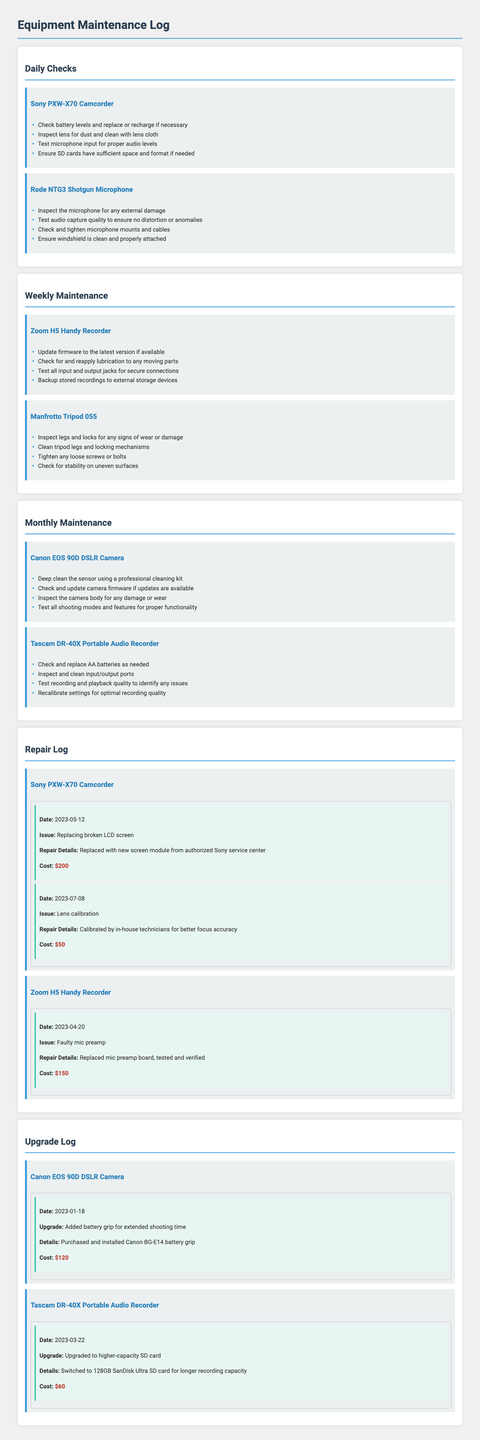What are the daily checks for the Sony PXW-X70 Camcorder? The daily checks for the Sony PXW-X70 Camcorder include checking battery levels, inspecting the lens, testing microphone input, and ensuring SD cards have sufficient space.
Answer: Check battery levels and replace or recharge if necessary, Inspect lens for dust and clean with lens cloth, Test microphone input for proper audio levels, Ensure SD cards have sufficient space and format if needed What was the repair cost for the faulty mic preamp on the Zoom H5 Handy Recorder? The repair cost for the faulty mic preamp is listed under the repair log for the Zoom H5 Handy Recorder.
Answer: $150 What maintenance tasks are performed monthly for the Canon EOS 90D DSLR Camera? Monthly maintenance tasks for the Canon EOS 90D DSLR Camera include deep cleaning the sensor, checking and updating firmware, inspecting the camera body for damage, and testing all shooting modes.
Answer: Deep clean the sensor using a professional cleaning kit, Check and update camera firmware if updates are available, Inspect the camera body for any damage or wear, Test all shooting modes and features for proper functionality When was the lens calibration done for the Sony PXW-X70 Camcorder? The date of the lens calibration for the Sony PXW-X70 Camcorder is recorded in the repair log.
Answer: 2023-07-08 What upgrade was made to the Tascam DR-40X Portable Audio Recorder? To understand the upgrade made to the Tascam DR-40X Portable Audio Recorder, we look at the upgrade log detailing what was done.
Answer: Upgraded to higher-capacity SD card What is the cost of the upgrade for the Canon EOS 90D DSLR Camera? The cost for the upgrade of the Canon EOS 90D DSLR Camera is documented in the upgrade log, showing how much was spent.
Answer: $120 Why is firmware updated weekly for the Zoom H5 Handy Recorder? The firmware is updated weekly to ensure the equipment operates with the latest improvements and features.
Answer: To the latest version if available Which equipment had a broken LCD screen repaired? Identifying which equipment had a broken LCD screen repaired comes from the repair log detailing the specific equipment in need of repairs.
Answer: Sony PXW-X70 Camcorder 